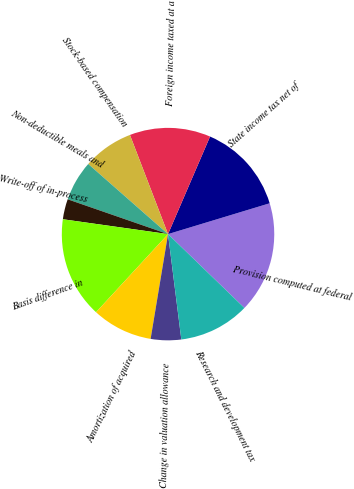Convert chart. <chart><loc_0><loc_0><loc_500><loc_500><pie_chart><fcel>Provision computed at federal<fcel>State income tax net of<fcel>Foreign income taxed at a<fcel>Stock-based compensation<fcel>Non-deductible meals and<fcel>Write-off of in-process<fcel>Basis difference in<fcel>Amortization of acquired<fcel>Change in valuation allowance<fcel>Research and development tax<nl><fcel>16.92%<fcel>13.84%<fcel>12.31%<fcel>7.69%<fcel>6.16%<fcel>3.08%<fcel>15.38%<fcel>9.23%<fcel>4.62%<fcel>10.77%<nl></chart> 